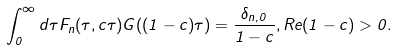Convert formula to latex. <formula><loc_0><loc_0><loc_500><loc_500>\int _ { 0 } ^ { \infty } d \tau F _ { n } ( \tau , c \tau ) G ( ( 1 - c ) \tau ) = \frac { \delta _ { n , 0 } } { 1 - c } , R e ( 1 - c ) > 0 .</formula> 